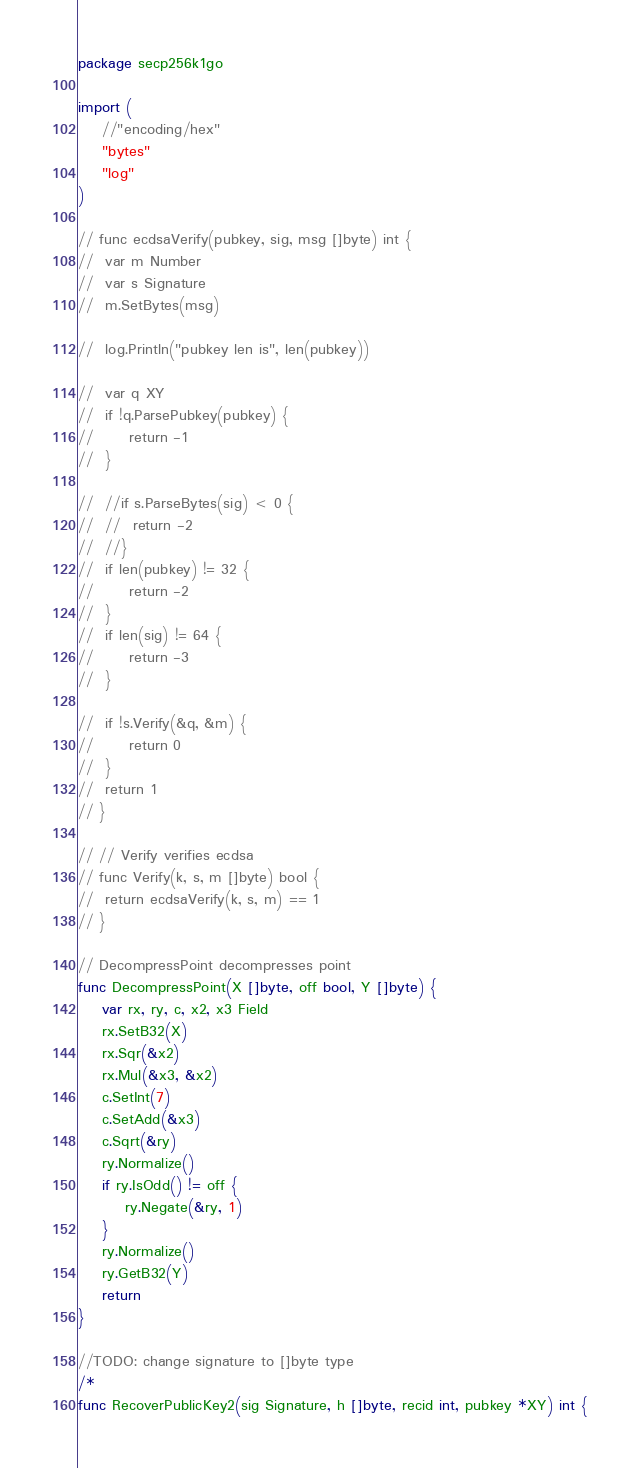Convert code to text. <code><loc_0><loc_0><loc_500><loc_500><_Go_>package secp256k1go

import (
	//"encoding/hex"
	"bytes"
	"log"
)

// func ecdsaVerify(pubkey, sig, msg []byte) int {
// 	var m Number
// 	var s Signature
// 	m.SetBytes(msg)

// 	log.Println("pubkey len is", len(pubkey))

// 	var q XY
// 	if !q.ParsePubkey(pubkey) {
// 		return -1
// 	}

// 	//if s.ParseBytes(sig) < 0 {
// 	//	return -2
// 	//}
// 	if len(pubkey) != 32 {
// 		return -2
// 	}
// 	if len(sig) != 64 {
// 		return -3
// 	}

// 	if !s.Verify(&q, &m) {
// 		return 0
// 	}
// 	return 1
// }

// // Verify verifies ecdsa
// func Verify(k, s, m []byte) bool {
// 	return ecdsaVerify(k, s, m) == 1
// }

// DecompressPoint decompresses point
func DecompressPoint(X []byte, off bool, Y []byte) {
	var rx, ry, c, x2, x3 Field
	rx.SetB32(X)
	rx.Sqr(&x2)
	rx.Mul(&x3, &x2)
	c.SetInt(7)
	c.SetAdd(&x3)
	c.Sqrt(&ry)
	ry.Normalize()
	if ry.IsOdd() != off {
		ry.Negate(&ry, 1)
	}
	ry.Normalize()
	ry.GetB32(Y)
	return
}

//TODO: change signature to []byte type
/*
func RecoverPublicKey2(sig Signature, h []byte, recid int, pubkey *XY) int {</code> 